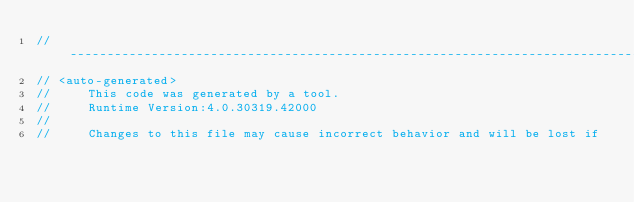<code> <loc_0><loc_0><loc_500><loc_500><_C#_>//------------------------------------------------------------------------------
// <auto-generated>
//     This code was generated by a tool.
//     Runtime Version:4.0.30319.42000
//
//     Changes to this file may cause incorrect behavior and will be lost if</code> 